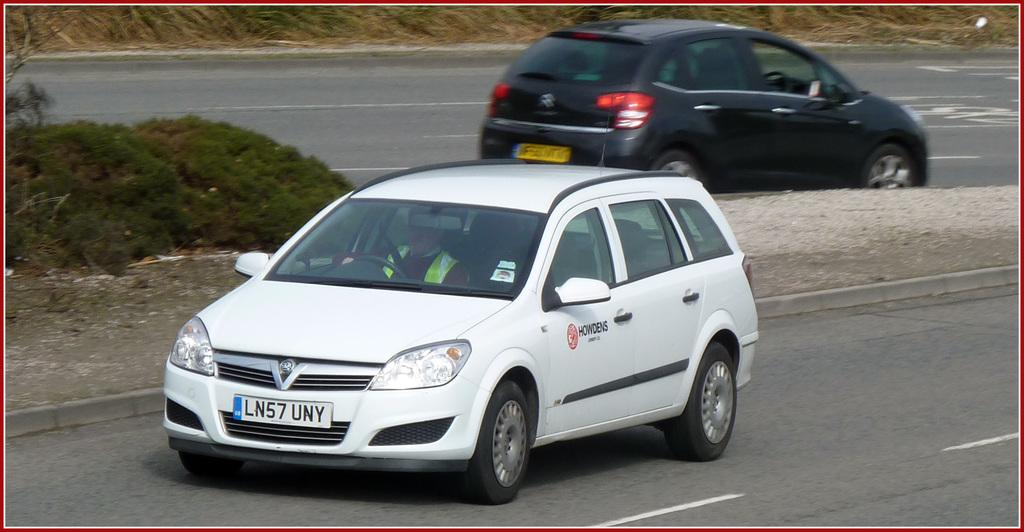Provide a one-sentence caption for the provided image. A white car from Howdens is driving down the road. 